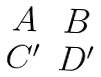<formula> <loc_0><loc_0><loc_500><loc_500>\begin{matrix} A & B \\ C ^ { \prime } & D ^ { \prime } \end{matrix}</formula> 